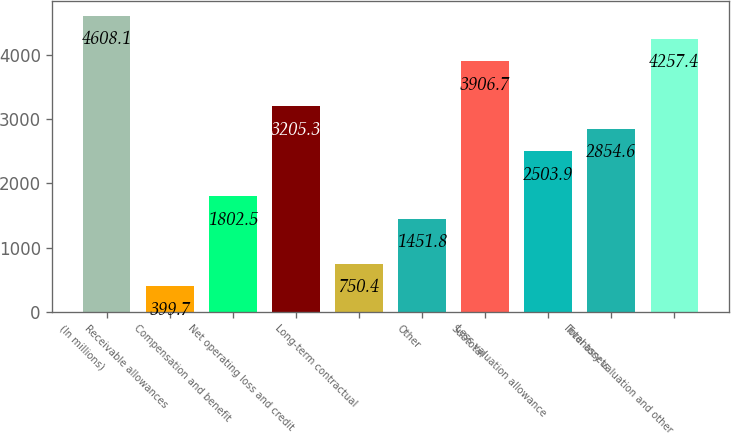<chart> <loc_0><loc_0><loc_500><loc_500><bar_chart><fcel>(In millions)<fcel>Receivable allowances<fcel>Compensation and benefit<fcel>Net operating loss and credit<fcel>Long-term contractual<fcel>Other<fcel>Subtotal<fcel>Less valuation allowance<fcel>Total assets<fcel>Inventory valuation and other<nl><fcel>4608.1<fcel>399.7<fcel>1802.5<fcel>3205.3<fcel>750.4<fcel>1451.8<fcel>3906.7<fcel>2503.9<fcel>2854.6<fcel>4257.4<nl></chart> 